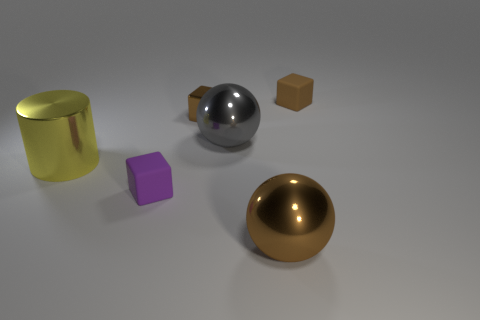What number of rubber spheres are there?
Your answer should be compact. 0. There is a tiny rubber block that is behind the gray metal sphere; what color is it?
Ensure brevity in your answer.  Brown. What size is the purple matte cube?
Provide a short and direct response. Small. There is a big cylinder; does it have the same color as the matte thing that is in front of the brown matte cube?
Your response must be concise. No. There is a rubber thing that is behind the tiny purple cube that is in front of the gray metal thing; what color is it?
Give a very brief answer. Brown. Is there anything else that is the same size as the yellow metallic thing?
Ensure brevity in your answer.  Yes. Is the shape of the brown metal object in front of the big yellow metallic cylinder the same as  the small purple matte object?
Provide a succinct answer. No. What number of big things are both in front of the large yellow metallic cylinder and left of the big brown metallic ball?
Your answer should be compact. 0. There is a matte thing to the left of the tiny rubber thing that is on the right side of the matte cube left of the brown matte thing; what color is it?
Offer a terse response. Purple. How many large yellow metallic cylinders are on the right side of the matte object that is to the right of the large brown thing?
Offer a very short reply. 0. 